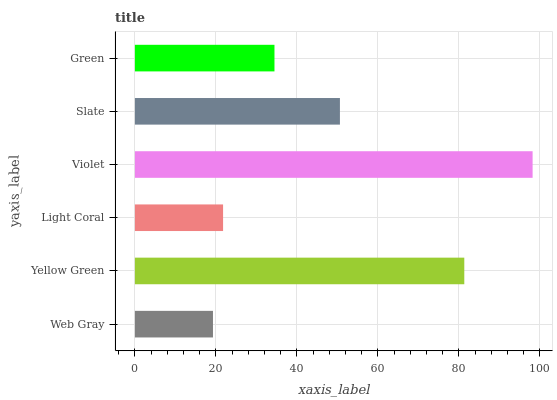Is Web Gray the minimum?
Answer yes or no. Yes. Is Violet the maximum?
Answer yes or no. Yes. Is Yellow Green the minimum?
Answer yes or no. No. Is Yellow Green the maximum?
Answer yes or no. No. Is Yellow Green greater than Web Gray?
Answer yes or no. Yes. Is Web Gray less than Yellow Green?
Answer yes or no. Yes. Is Web Gray greater than Yellow Green?
Answer yes or no. No. Is Yellow Green less than Web Gray?
Answer yes or no. No. Is Slate the high median?
Answer yes or no. Yes. Is Green the low median?
Answer yes or no. Yes. Is Violet the high median?
Answer yes or no. No. Is Violet the low median?
Answer yes or no. No. 